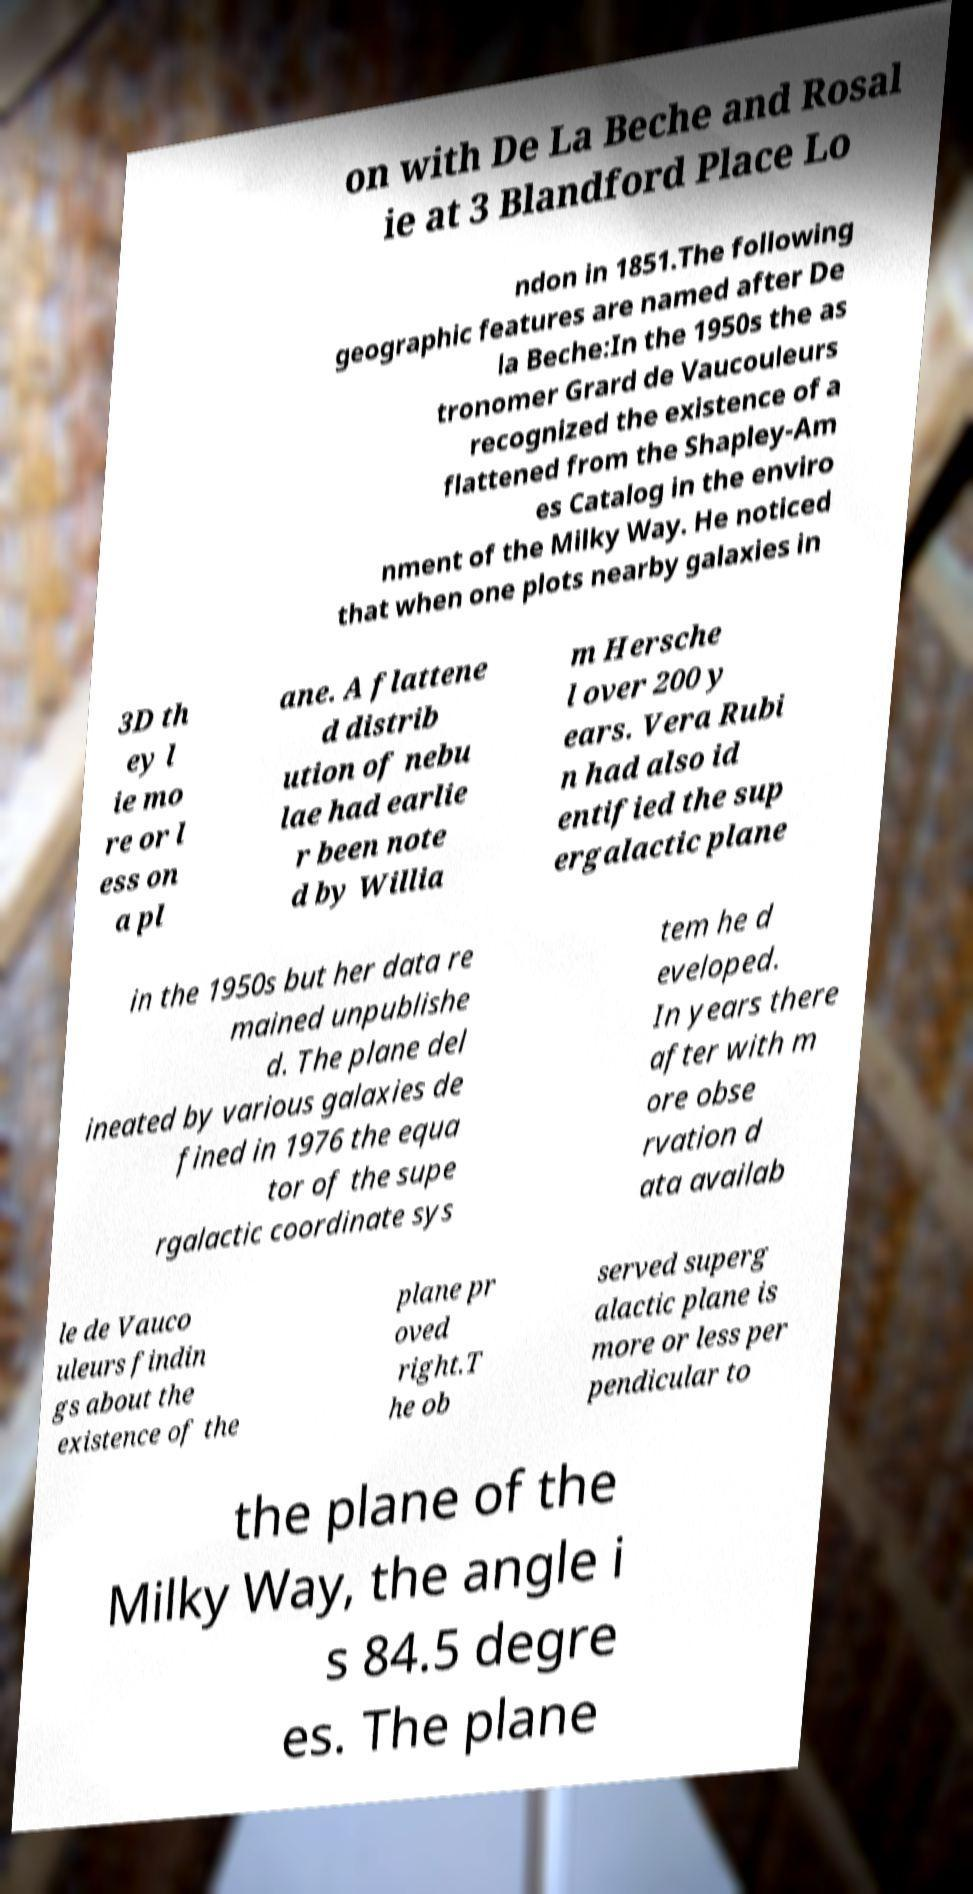Can you accurately transcribe the text from the provided image for me? on with De La Beche and Rosal ie at 3 Blandford Place Lo ndon in 1851.The following geographic features are named after De la Beche:In the 1950s the as tronomer Grard de Vaucouleurs recognized the existence of a flattened from the Shapley-Am es Catalog in the enviro nment of the Milky Way. He noticed that when one plots nearby galaxies in 3D th ey l ie mo re or l ess on a pl ane. A flattene d distrib ution of nebu lae had earlie r been note d by Willia m Hersche l over 200 y ears. Vera Rubi n had also id entified the sup ergalactic plane in the 1950s but her data re mained unpublishe d. The plane del ineated by various galaxies de fined in 1976 the equa tor of the supe rgalactic coordinate sys tem he d eveloped. In years there after with m ore obse rvation d ata availab le de Vauco uleurs findin gs about the existence of the plane pr oved right.T he ob served superg alactic plane is more or less per pendicular to the plane of the Milky Way, the angle i s 84.5 degre es. The plane 